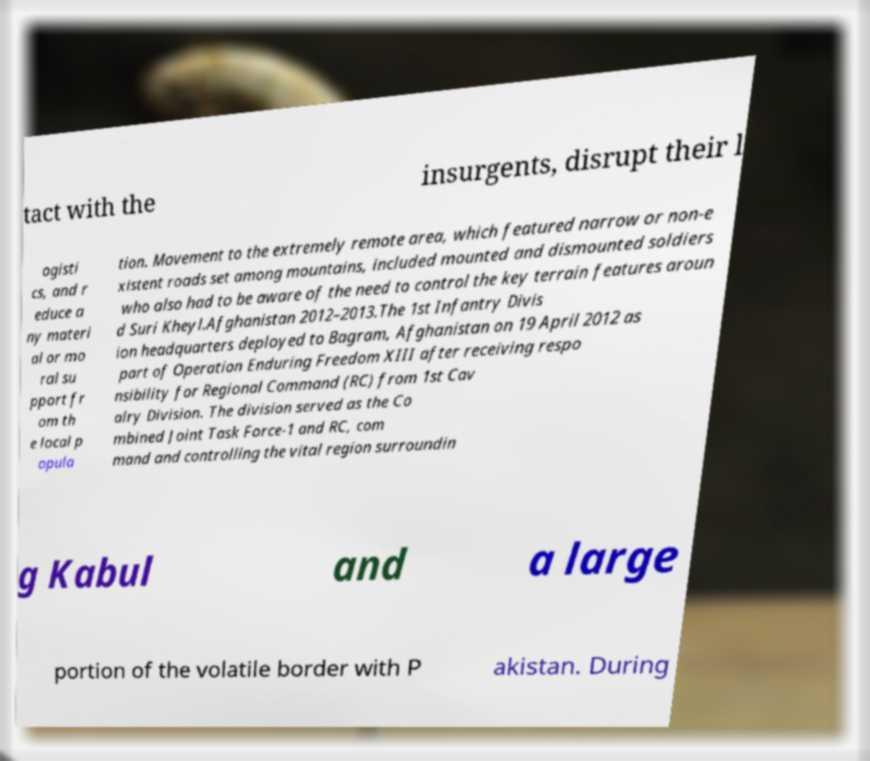For documentation purposes, I need the text within this image transcribed. Could you provide that? tact with the insurgents, disrupt their l ogisti cs, and r educe a ny materi al or mo ral su pport fr om th e local p opula tion. Movement to the extremely remote area, which featured narrow or non-e xistent roads set among mountains, included mounted and dismounted soldiers who also had to be aware of the need to control the key terrain features aroun d Suri Kheyl.Afghanistan 2012–2013.The 1st Infantry Divis ion headquarters deployed to Bagram, Afghanistan on 19 April 2012 as part of Operation Enduring Freedom XIII after receiving respo nsibility for Regional Command (RC) from 1st Cav alry Division. The division served as the Co mbined Joint Task Force-1 and RC, com mand and controlling the vital region surroundin g Kabul and a large portion of the volatile border with P akistan. During 